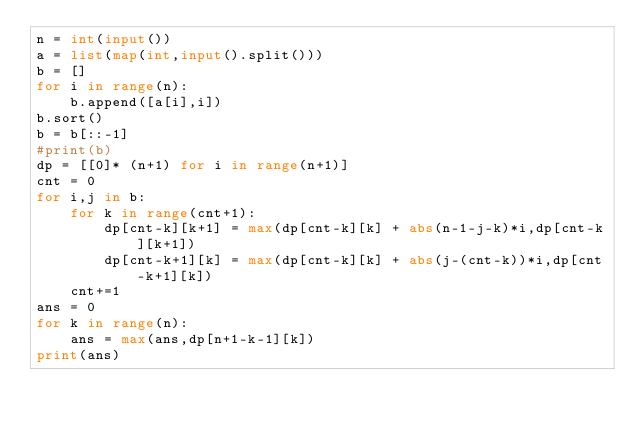Convert code to text. <code><loc_0><loc_0><loc_500><loc_500><_Python_>n = int(input())
a = list(map(int,input().split()))
b = []
for i in range(n):
    b.append([a[i],i])
b.sort()
b = b[::-1]
#print(b)
dp = [[0]* (n+1) for i in range(n+1)]
cnt = 0
for i,j in b:
    for k in range(cnt+1):
        dp[cnt-k][k+1] = max(dp[cnt-k][k] + abs(n-1-j-k)*i,dp[cnt-k][k+1])
        dp[cnt-k+1][k] = max(dp[cnt-k][k] + abs(j-(cnt-k))*i,dp[cnt-k+1][k])
    cnt+=1
ans = 0
for k in range(n):
    ans = max(ans,dp[n+1-k-1][k])
print(ans)</code> 